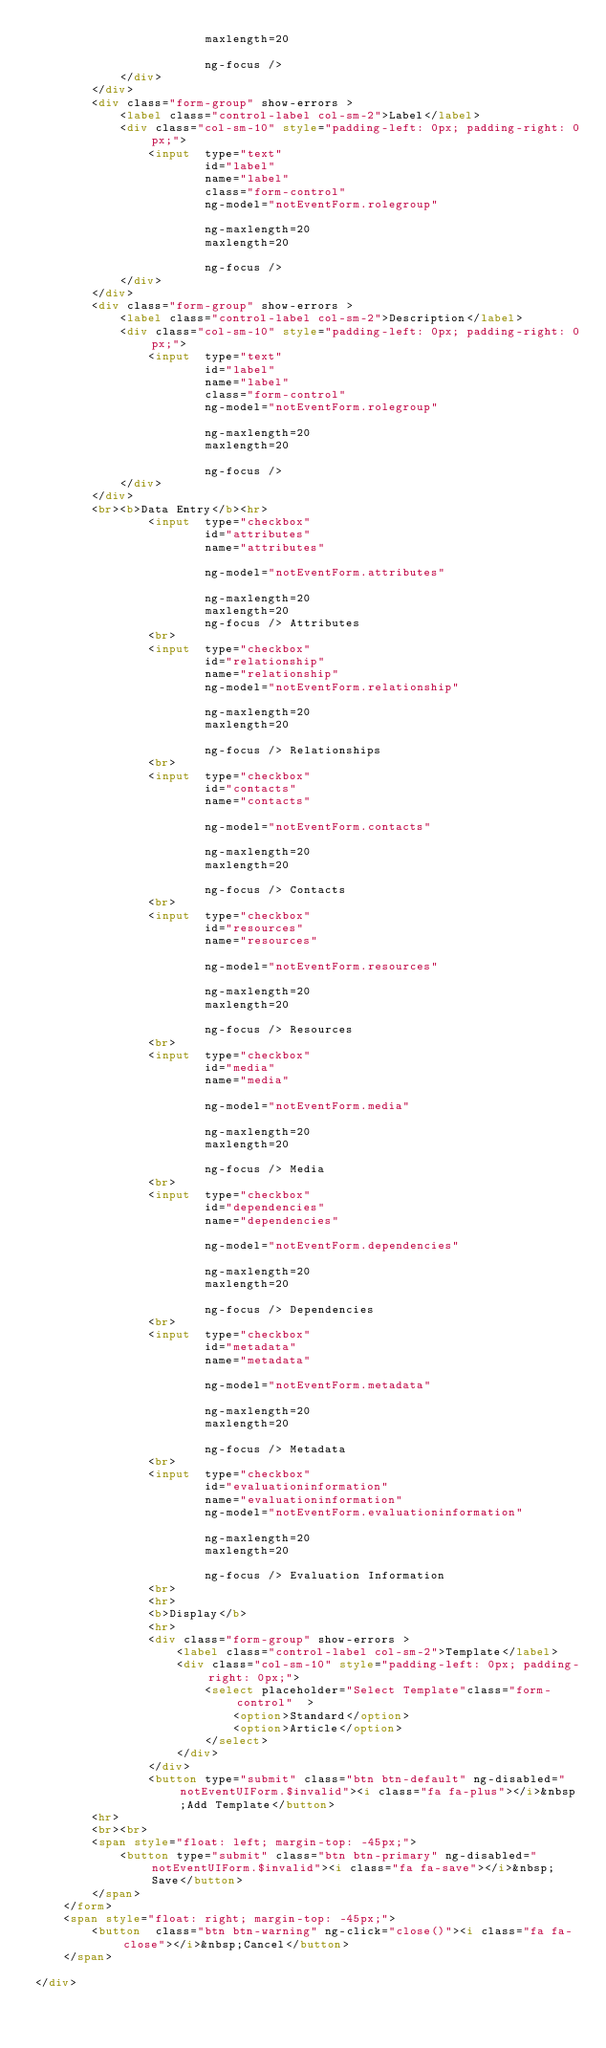Convert code to text. <code><loc_0><loc_0><loc_500><loc_500><_HTML_>						maxlength=20															
						ng-focus />	
			</div>
		</div>
		<div class="form-group" show-errors >
			<label class="control-label col-sm-2">Label</label>
			<div class="col-sm-10" style="padding-left: 0px; padding-right: 0px;">
				<input  type="text" 				
						id="label"
						name="label"									
						class="form-control" 
						ng-model="notEventForm.rolegroup" 									 
						ng-maxlength=20
						maxlength=20															
						ng-focus />	
			</div>
		</div>
		<div class="form-group" show-errors >
			<label class="control-label col-sm-2">Description</label>
			<div class="col-sm-10" style="padding-left: 0px; padding-right: 0px;">
				<input  type="text" 				
						id="label"
						name="label"									
						class="form-control" 
						ng-model="notEventForm.rolegroup" 									 
						ng-maxlength=20
						maxlength=20															
						ng-focus />	
			</div>
		</div>
		<br><b>Data Entry</b><hr>
				<input  type="checkbox" 				
						id="attributes"
						name="attributes"															
						ng-model="notEventForm.attributes" 									 
						ng-maxlength=20
						maxlength=20
						ng-focus /> Attributes	
				<br>
				<input  type="checkbox" 				
						id="relationship"
						name="relationship"									
						ng-model="notEventForm.relationship" 									 
						ng-maxlength=20
						maxlength=20															
						ng-focus /> Relationships	
				<br>
				<input  type="checkbox" 				
						id="contacts"
						name="contacts"															
						ng-model="notEventForm.contacts" 									 
						ng-maxlength=20
						maxlength=20															
						ng-focus /> Contacts	
				<br>
				<input  type="checkbox" 				
						id="resources"
						name="resources"															
						ng-model="notEventForm.resources" 									 
						ng-maxlength=20
						maxlength=20															
						ng-focus /> Resources	
				<br>
				<input  type="checkbox" 				
						id="media"
						name="media"															
						ng-model="notEventForm.media" 									 
						ng-maxlength=20
						maxlength=20															
						ng-focus /> Media	
				<br>
				<input  type="checkbox" 				
						id="dependencies"
						name="dependencies"															
						ng-model="notEventForm.dependencies" 									 
						ng-maxlength=20
						maxlength=20															
						ng-focus /> Dependencies	
				<br>
				<input  type="checkbox" 				
						id="metadata"
						name="metadata"															
						ng-model="notEventForm.metadata" 									 
						ng-maxlength=20
						maxlength=20															
						ng-focus /> Metadata
				<br>
				<input  type="checkbox" 				
						id="evaluationinformation"
						name="evaluationinformation"
						ng-model="notEventForm.evaluationinformation" 									 
						ng-maxlength=20
						maxlength=20															
						ng-focus /> Evaluation Information	
				<br>
				<hr>
				<b>Display</b>
				<hr>
				<div class="form-group" show-errors >
					<label class="control-label col-sm-2">Template</label>
					<div class="col-sm-10" style="padding-left: 0px; padding-right: 0px;">
						<select placeholder="Select Template"class="form-control"  >
							<option>Standard</option>
							<option>Article</option>
						</select>	
					</div>
				</div>
				<button type="submit" class="btn btn-default" ng-disabled="notEventUIForm.$invalid"><i class="fa fa-plus"></i>&nbsp;Add Template</button>		 
		<hr>
		<br><br>		
		<span style="float: left; margin-top: -45px;">   
			<button type="submit" class="btn btn-primary" ng-disabled="notEventUIForm.$invalid"><i class="fa fa-save"></i>&nbsp;Save</button>		 
		</span>			
	</form>	
	<span style="float: right; margin-top: -45px;">   	
		<button  class="btn btn-warning" ng-click="close()"><i class="fa fa-close"></i>&nbsp;Cancel</button>	
	</span>	

</div></code> 